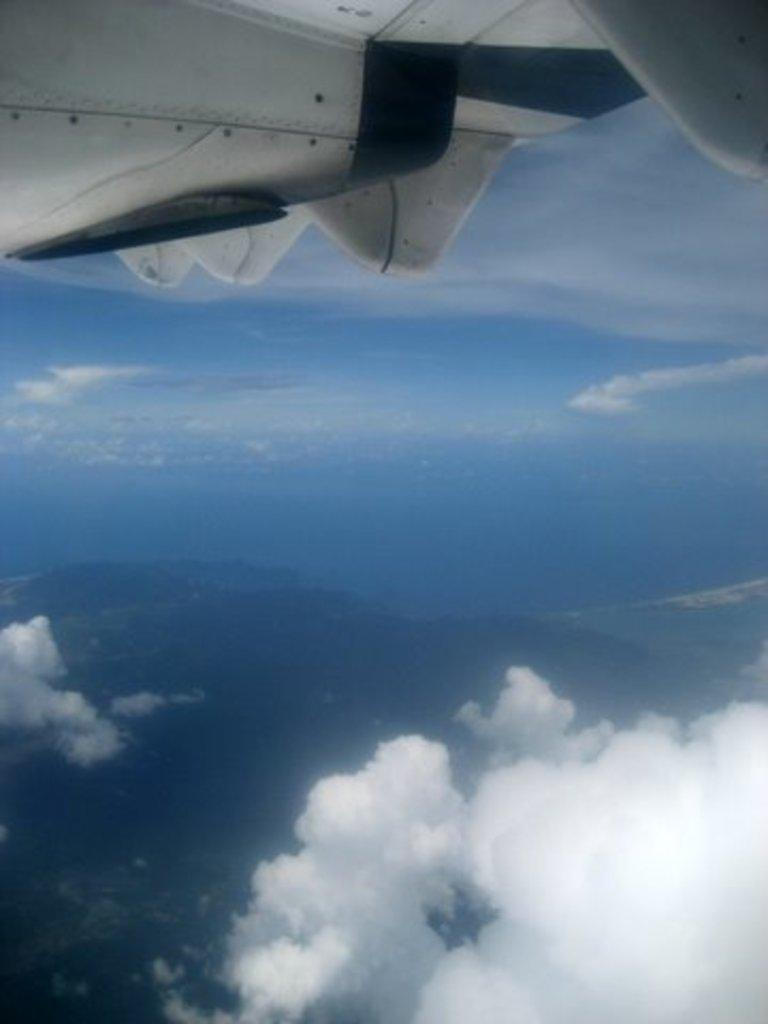What can be seen in the sky in the image? There are clouds in the image. What else is visible in the sky besides the clouds? The sky is visible in the image. What object in the image resembles an airplane? There is a white object in the image that resembles an airplane. How many trucks can be seen carrying glue in the image? There are no trucks or glue present in the image. What is the white object attempting to do in the image? The white object is not attempting to do anything in the image, as it is a static representation of an airplane. 